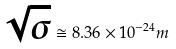<formula> <loc_0><loc_0><loc_500><loc_500>\sqrt { \sigma } \cong 8 . 3 6 \times 1 0 ^ { - 2 4 } m</formula> 